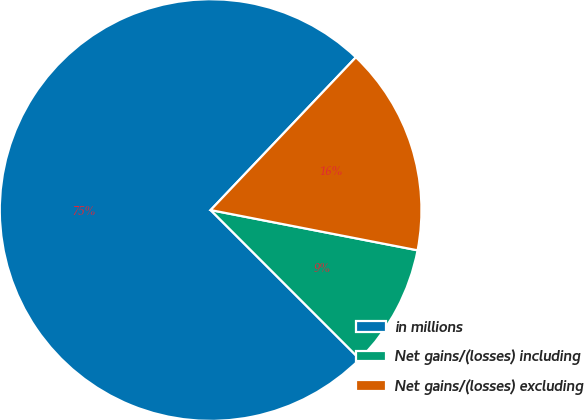<chart> <loc_0><loc_0><loc_500><loc_500><pie_chart><fcel>in millions<fcel>Net gains/(losses) including<fcel>Net gains/(losses) excluding<nl><fcel>74.6%<fcel>9.44%<fcel>15.96%<nl></chart> 